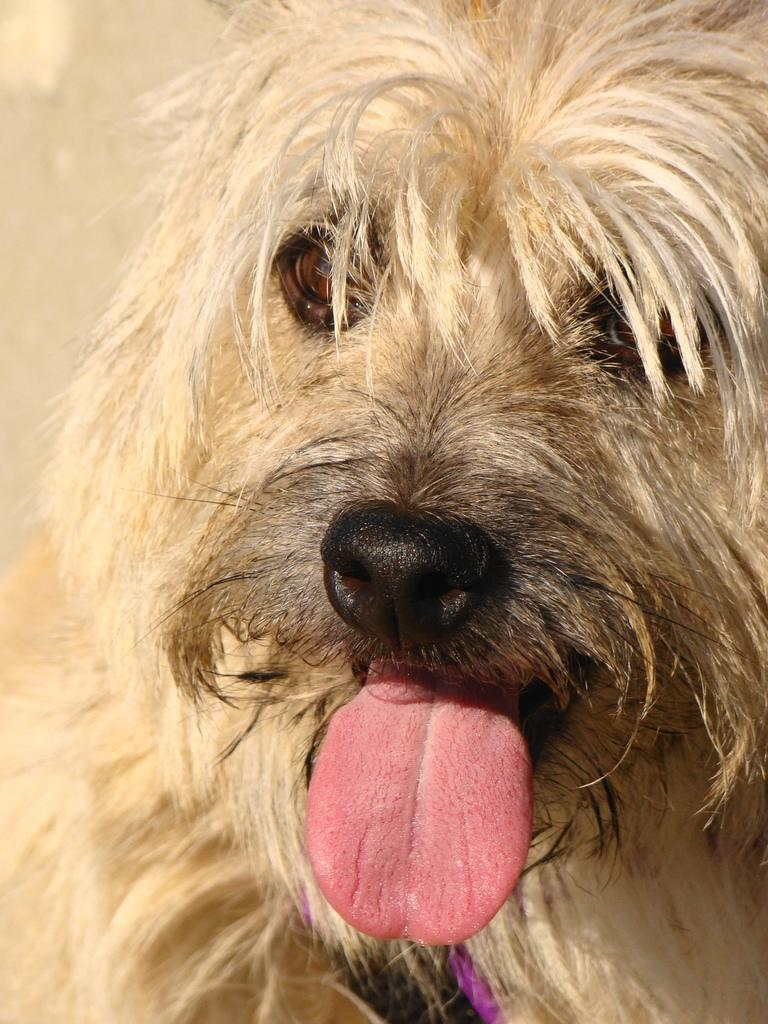What animal is present in the image? There is a dog in the image. What is the dog doing with its tongue? The dog has its tongue outside in the image. Where is the dog located in relation to the image? The dog is in the foreground of the image. What type of pie is the dog holding in the image? There is no pie present in the image; it features a dog with its tongue outside. 